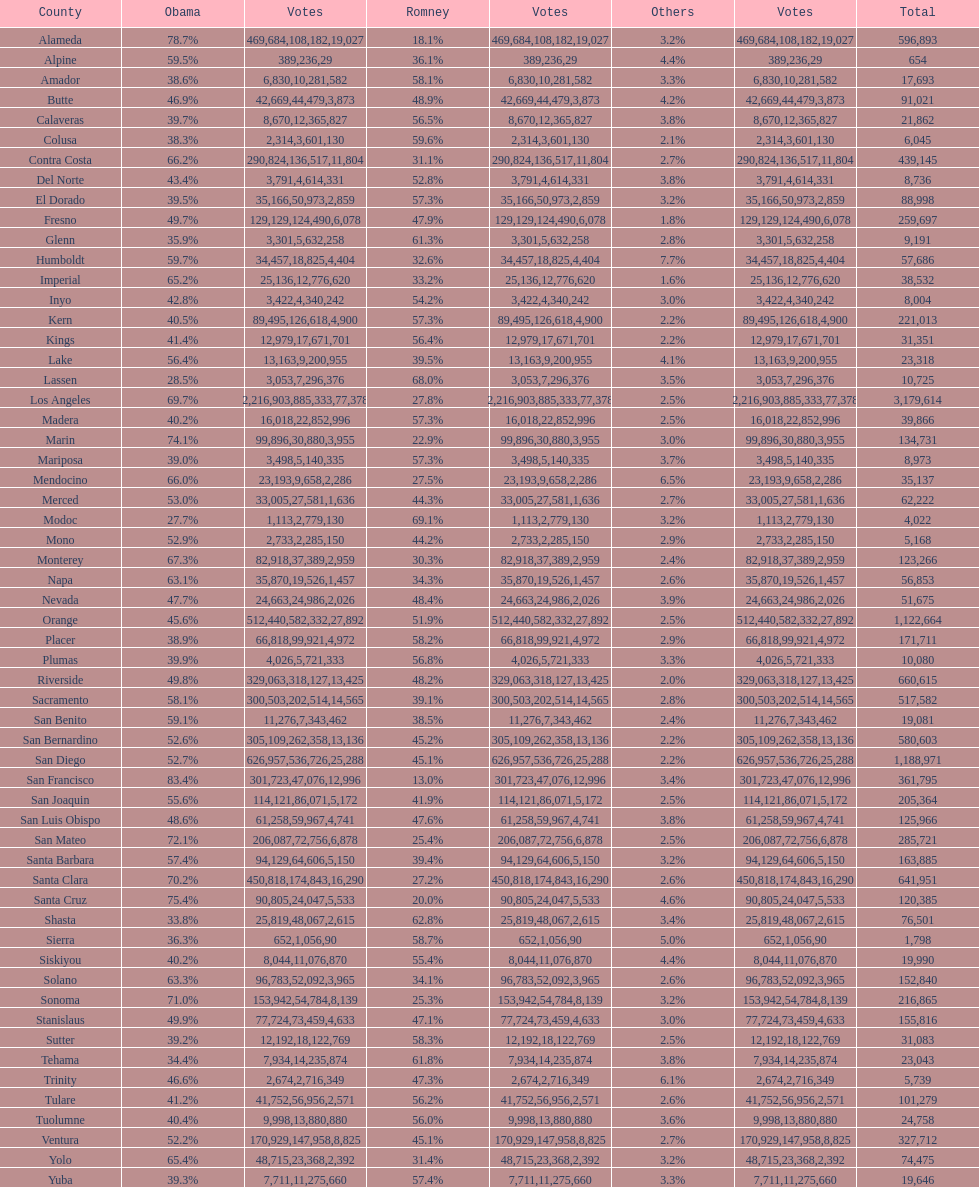Which county had the most total votes? Los Angeles. 